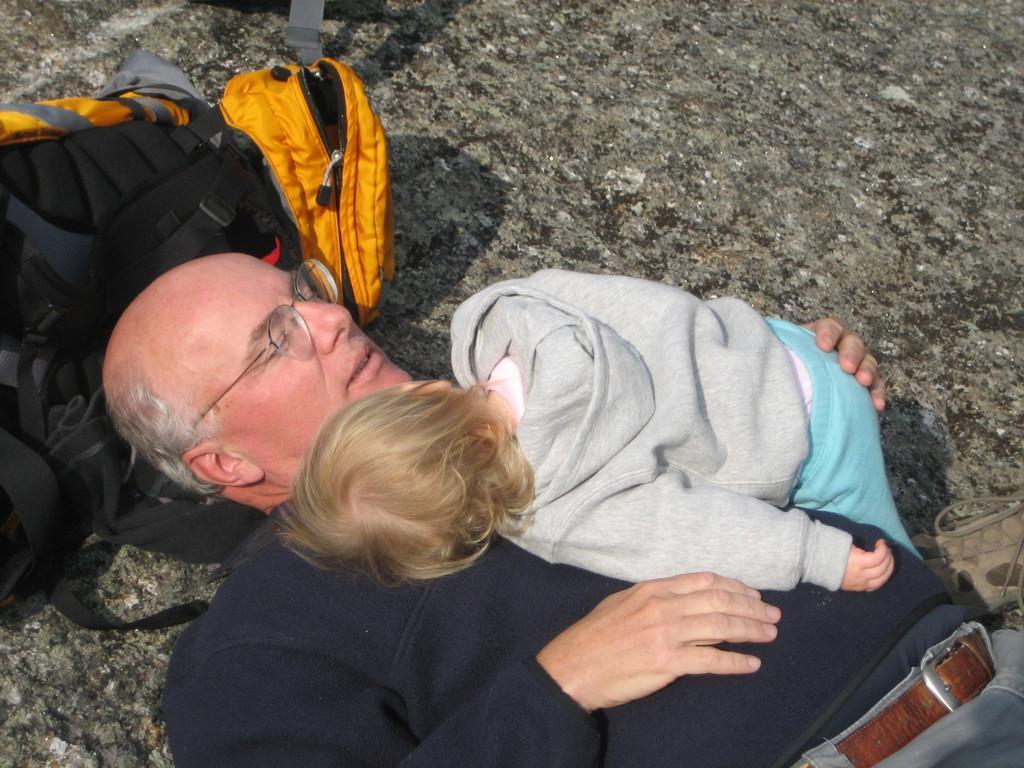Could you give a brief overview of what you see in this image? Old man lying on the ground and holding a baby on him, he is wearing glasses and bag is present near his head. 